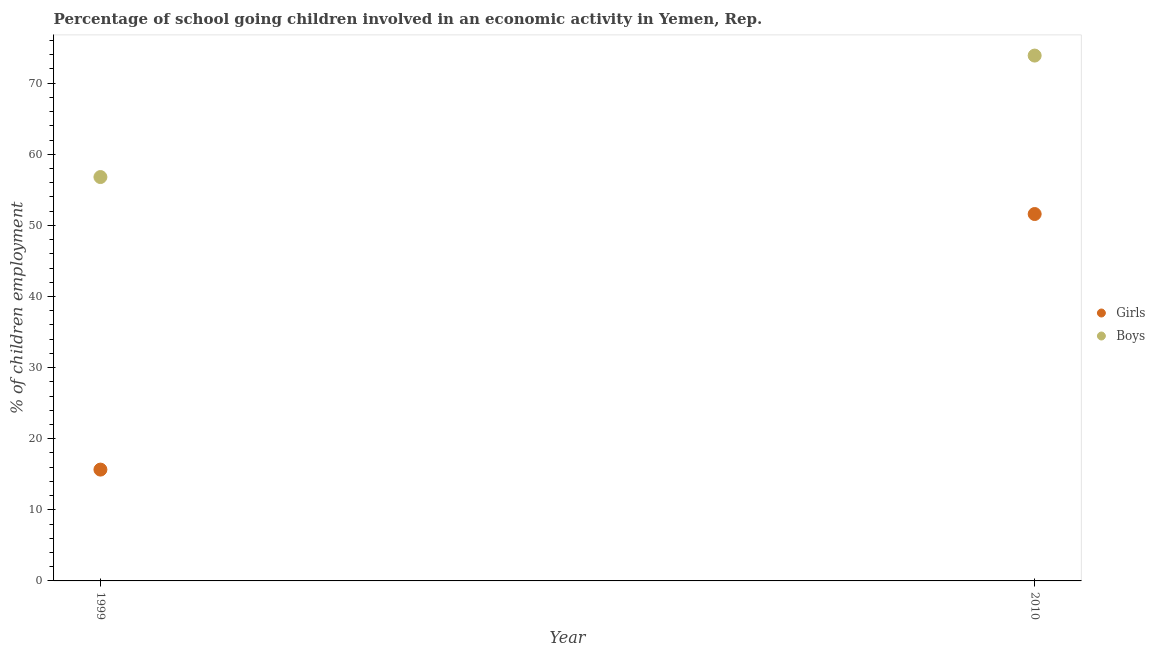What is the percentage of school going boys in 2010?
Provide a short and direct response. 73.88. Across all years, what is the maximum percentage of school going girls?
Offer a very short reply. 51.6. Across all years, what is the minimum percentage of school going boys?
Your answer should be compact. 56.8. In which year was the percentage of school going boys minimum?
Give a very brief answer. 1999. What is the total percentage of school going girls in the graph?
Offer a terse response. 67.25. What is the difference between the percentage of school going girls in 1999 and that in 2010?
Your answer should be compact. -35.94. What is the difference between the percentage of school going girls in 2010 and the percentage of school going boys in 1999?
Make the answer very short. -5.2. What is the average percentage of school going girls per year?
Ensure brevity in your answer.  33.63. In the year 1999, what is the difference between the percentage of school going boys and percentage of school going girls?
Offer a terse response. 41.14. What is the ratio of the percentage of school going boys in 1999 to that in 2010?
Your response must be concise. 0.77. Is the percentage of school going boys strictly greater than the percentage of school going girls over the years?
Give a very brief answer. Yes. Is the percentage of school going girls strictly less than the percentage of school going boys over the years?
Offer a terse response. Yes. How many years are there in the graph?
Give a very brief answer. 2. What is the difference between two consecutive major ticks on the Y-axis?
Give a very brief answer. 10. Are the values on the major ticks of Y-axis written in scientific E-notation?
Your response must be concise. No. Does the graph contain grids?
Your answer should be very brief. No. How many legend labels are there?
Provide a short and direct response. 2. What is the title of the graph?
Your answer should be very brief. Percentage of school going children involved in an economic activity in Yemen, Rep. Does "From production" appear as one of the legend labels in the graph?
Keep it short and to the point. No. What is the label or title of the X-axis?
Provide a short and direct response. Year. What is the label or title of the Y-axis?
Give a very brief answer. % of children employment. What is the % of children employment in Girls in 1999?
Offer a terse response. 15.66. What is the % of children employment of Boys in 1999?
Provide a succinct answer. 56.8. What is the % of children employment in Girls in 2010?
Give a very brief answer. 51.6. What is the % of children employment of Boys in 2010?
Your answer should be compact. 73.88. Across all years, what is the maximum % of children employment in Girls?
Provide a succinct answer. 51.6. Across all years, what is the maximum % of children employment in Boys?
Offer a terse response. 73.88. Across all years, what is the minimum % of children employment of Girls?
Provide a short and direct response. 15.66. Across all years, what is the minimum % of children employment of Boys?
Ensure brevity in your answer.  56.8. What is the total % of children employment of Girls in the graph?
Your response must be concise. 67.25. What is the total % of children employment in Boys in the graph?
Provide a short and direct response. 130.67. What is the difference between the % of children employment of Girls in 1999 and that in 2010?
Ensure brevity in your answer.  -35.94. What is the difference between the % of children employment of Boys in 1999 and that in 2010?
Offer a very short reply. -17.08. What is the difference between the % of children employment of Girls in 1999 and the % of children employment of Boys in 2010?
Your response must be concise. -58.22. What is the average % of children employment of Girls per year?
Make the answer very short. 33.63. What is the average % of children employment in Boys per year?
Your answer should be compact. 65.34. In the year 1999, what is the difference between the % of children employment in Girls and % of children employment in Boys?
Keep it short and to the point. -41.14. In the year 2010, what is the difference between the % of children employment in Girls and % of children employment in Boys?
Offer a very short reply. -22.28. What is the ratio of the % of children employment of Girls in 1999 to that in 2010?
Give a very brief answer. 0.3. What is the ratio of the % of children employment in Boys in 1999 to that in 2010?
Give a very brief answer. 0.77. What is the difference between the highest and the second highest % of children employment of Girls?
Ensure brevity in your answer.  35.94. What is the difference between the highest and the second highest % of children employment in Boys?
Your answer should be compact. 17.08. What is the difference between the highest and the lowest % of children employment of Girls?
Offer a very short reply. 35.94. What is the difference between the highest and the lowest % of children employment of Boys?
Give a very brief answer. 17.08. 